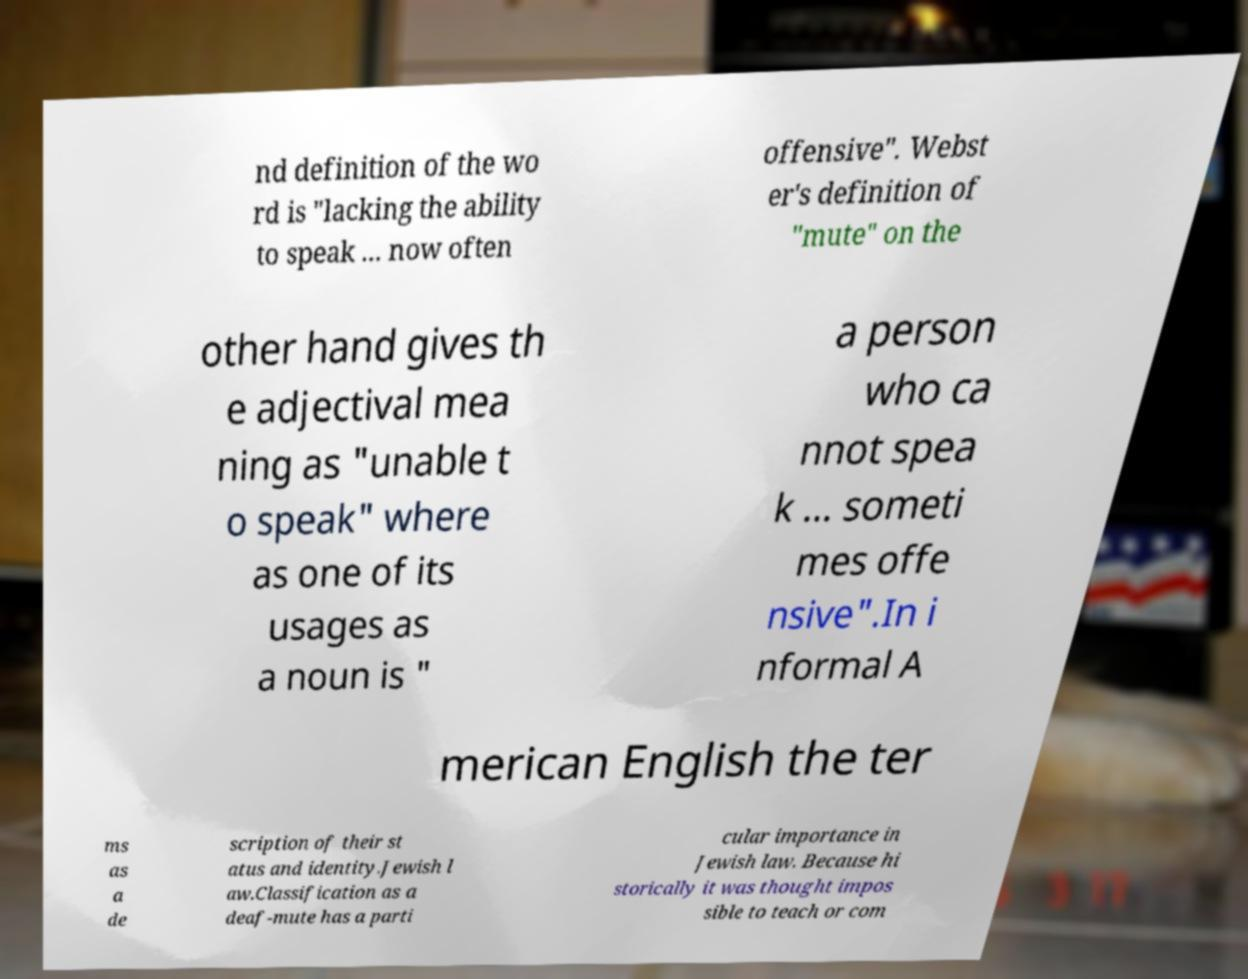Could you extract and type out the text from this image? nd definition of the wo rd is "lacking the ability to speak ... now often offensive". Webst er's definition of "mute" on the other hand gives th e adjectival mea ning as "unable t o speak" where as one of its usages as a noun is " a person who ca nnot spea k ... someti mes offe nsive".In i nformal A merican English the ter ms as a de scription of their st atus and identity.Jewish l aw.Classification as a deaf-mute has a parti cular importance in Jewish law. Because hi storically it was thought impos sible to teach or com 